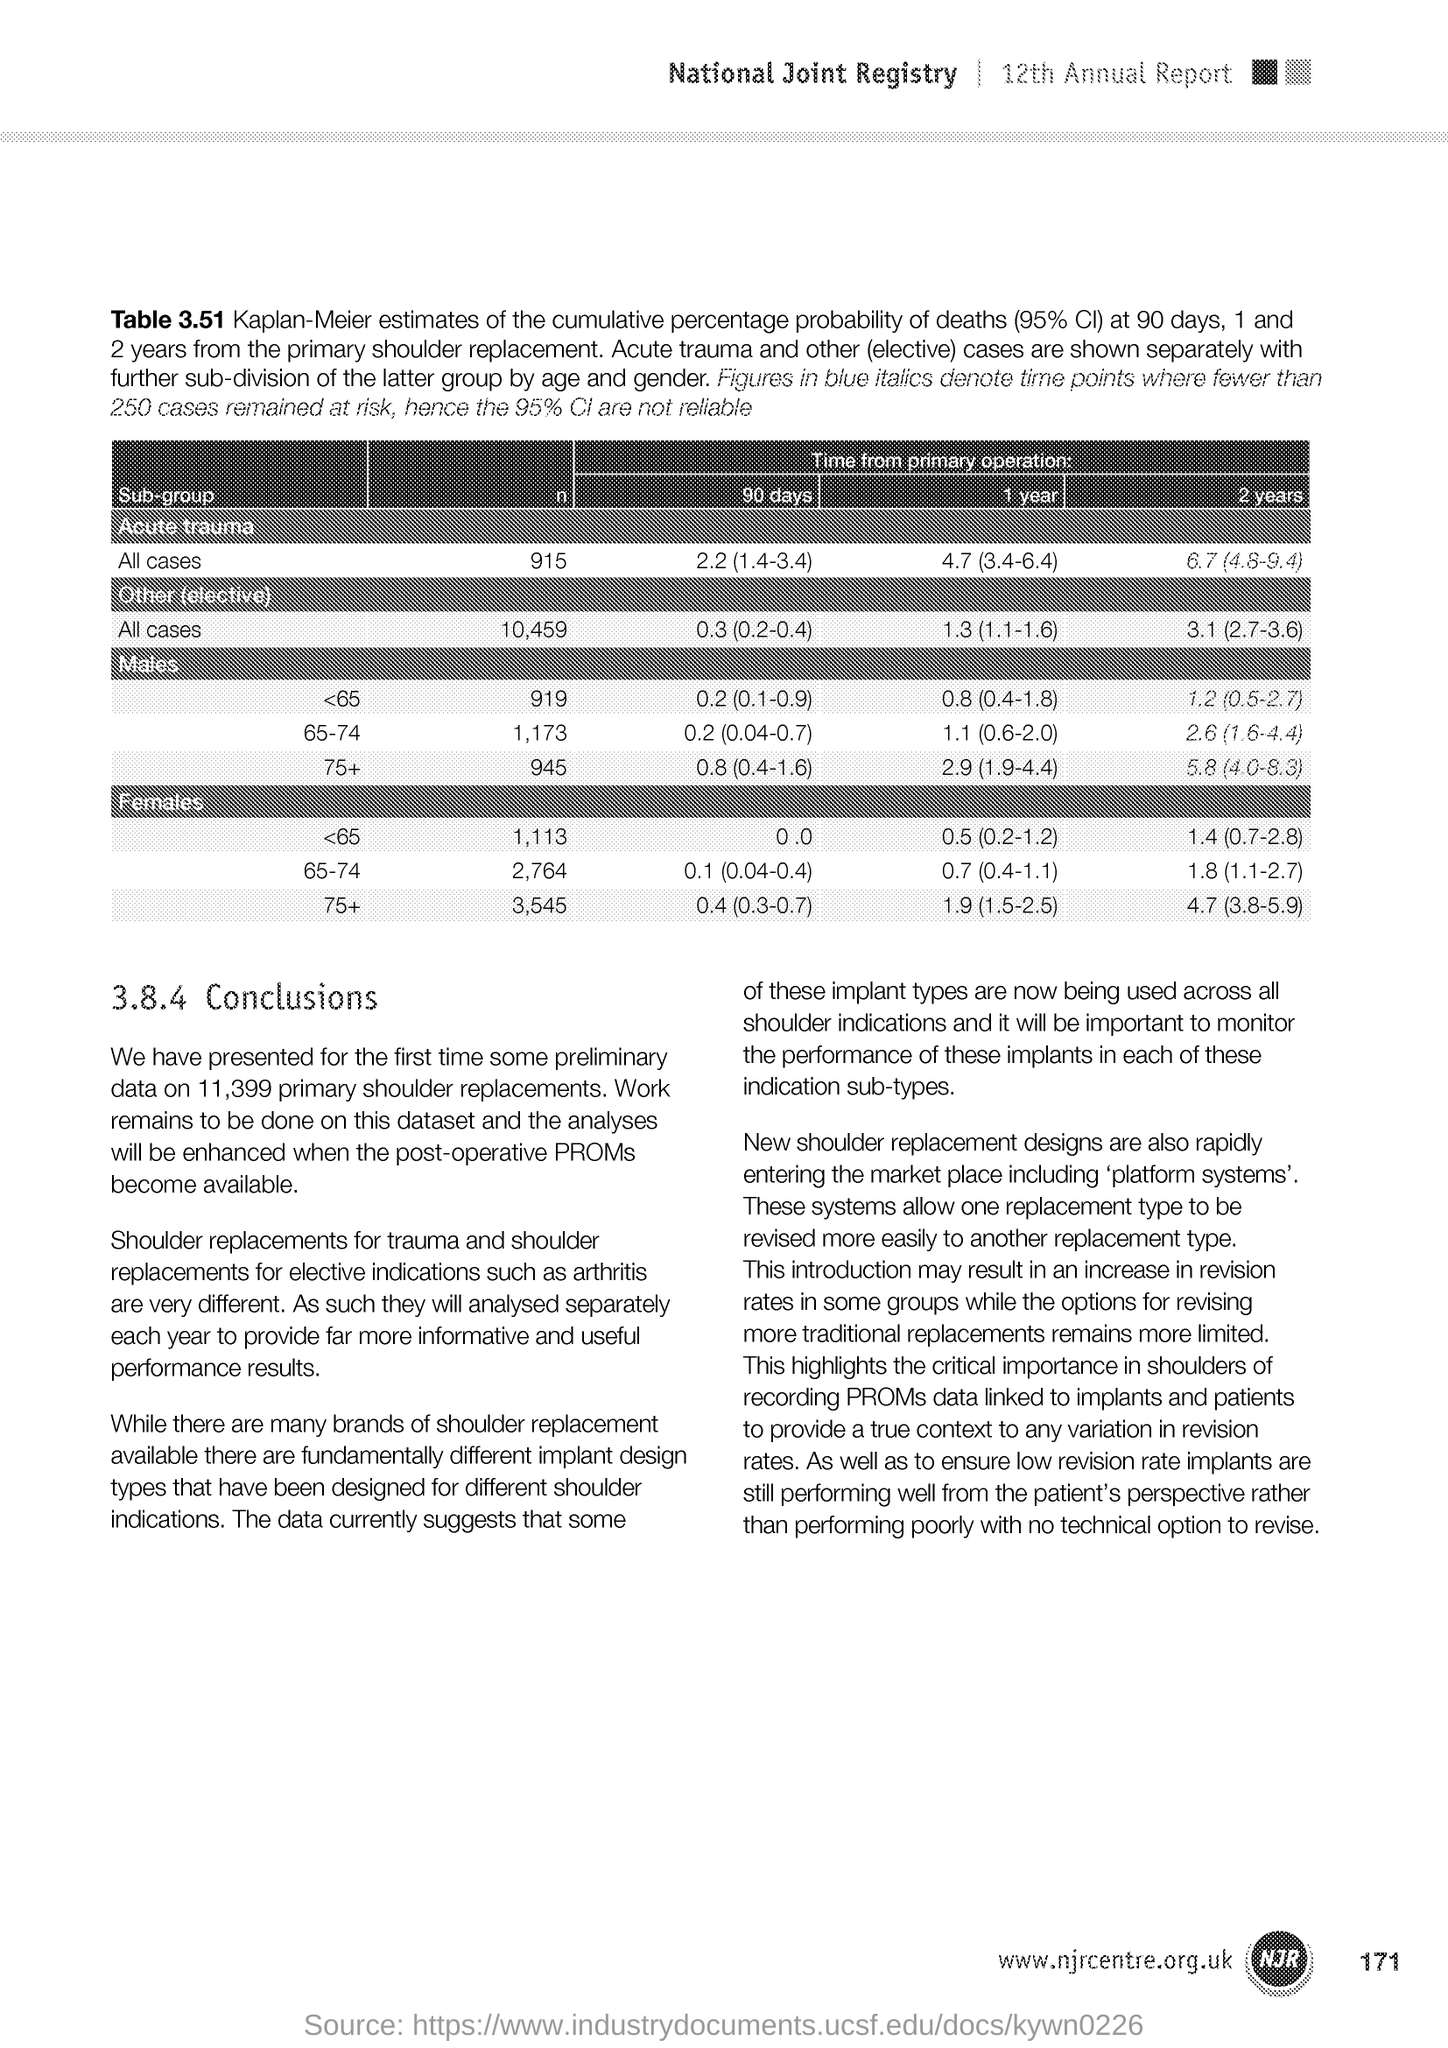What is the Page Number?
Provide a succinct answer. 171. 